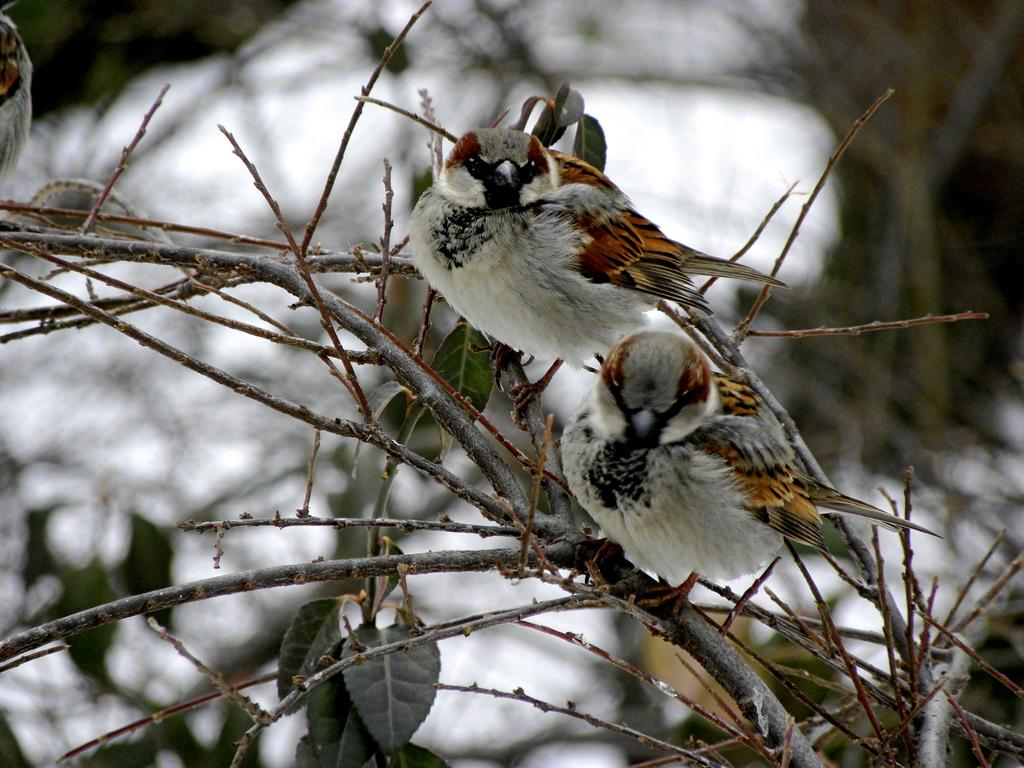What type of birds are in the image? There are sparrows in the image. Where are the sparrows located? The sparrows are sitting on a tree. What is the ground condition in the background of the image? There is snow on the floor in the background of the image. What type of agreement is being signed by the sparrows in the image? There is no indication of any agreement being signed in the image; it features sparrows sitting on a tree. Can you describe the facial expressions of the sparrows in the image? Birds, including sparrows, do not have facial expressions like humans, so it is not possible to describe their facial expressions. 